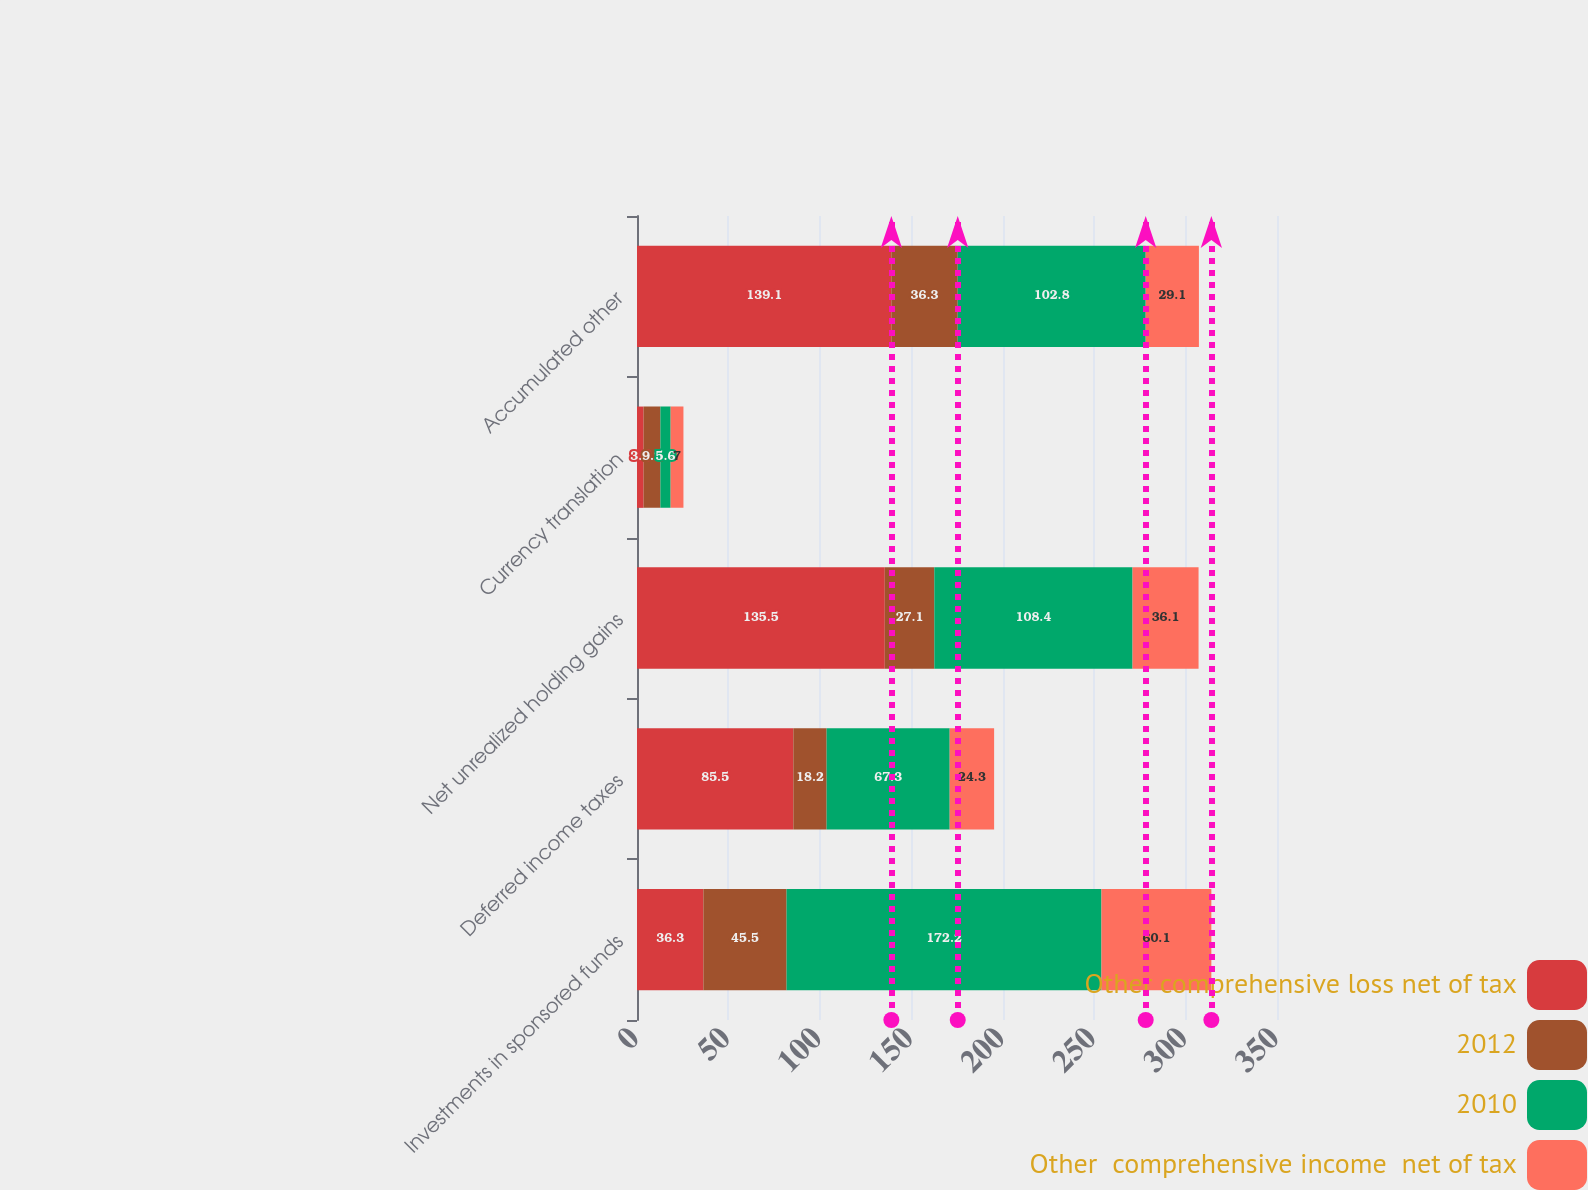Convert chart. <chart><loc_0><loc_0><loc_500><loc_500><stacked_bar_chart><ecel><fcel>Investments in sponsored funds<fcel>Deferred income taxes<fcel>Net unrealized holding gains<fcel>Currency translation<fcel>Accumulated other<nl><fcel>Other comprehensive loss net of tax<fcel>36.3<fcel>85.5<fcel>135.5<fcel>3.6<fcel>139.1<nl><fcel>2012<fcel>45.5<fcel>18.2<fcel>27.1<fcel>9.2<fcel>36.3<nl><fcel>2010<fcel>172.2<fcel>67.3<fcel>108.4<fcel>5.6<fcel>102.8<nl><fcel>Other  comprehensive income  net of tax<fcel>60.1<fcel>24.3<fcel>36.1<fcel>7<fcel>29.1<nl></chart> 